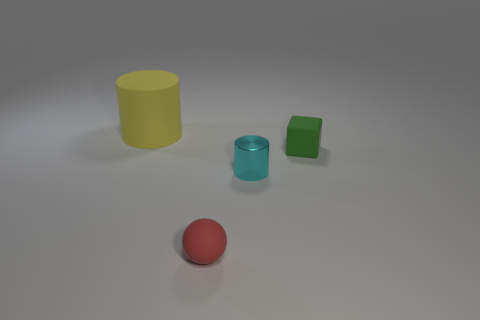Is the green object made of the same material as the big yellow thing?
Your response must be concise. Yes. What number of red objects have the same material as the cyan object?
Your answer should be very brief. 0. What is the size of the cyan object that is the same shape as the yellow matte thing?
Your answer should be very brief. Small. There is a matte thing in front of the tiny green matte thing; is its shape the same as the yellow rubber thing?
Ensure brevity in your answer.  No. The large rubber object left of the tiny rubber thing in front of the tiny cube is what shape?
Keep it short and to the point. Cylinder. Are there any other things that have the same shape as the tiny red thing?
Provide a succinct answer. No. There is another thing that is the same shape as the big thing; what color is it?
Offer a terse response. Cyan. The rubber thing that is both on the left side of the green rubber object and to the right of the yellow thing has what shape?
Your response must be concise. Sphere. Is the number of green cubes less than the number of big purple cubes?
Make the answer very short. No. Are there any large blue matte cubes?
Ensure brevity in your answer.  No. 